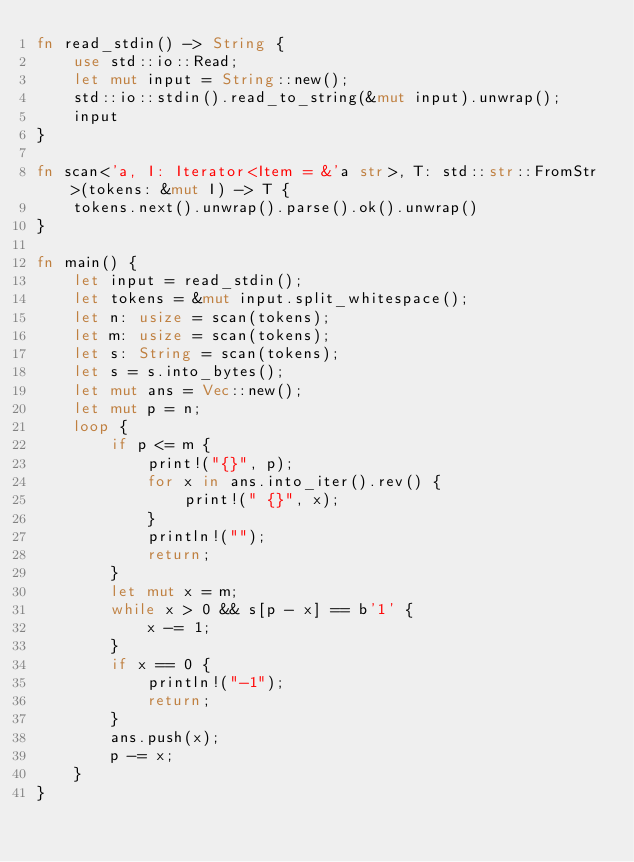<code> <loc_0><loc_0><loc_500><loc_500><_Rust_>fn read_stdin() -> String {
    use std::io::Read;
    let mut input = String::new();
    std::io::stdin().read_to_string(&mut input).unwrap();
    input
}

fn scan<'a, I: Iterator<Item = &'a str>, T: std::str::FromStr>(tokens: &mut I) -> T {
    tokens.next().unwrap().parse().ok().unwrap()
}

fn main() {
    let input = read_stdin();
    let tokens = &mut input.split_whitespace();
    let n: usize = scan(tokens);
    let m: usize = scan(tokens);
    let s: String = scan(tokens);
    let s = s.into_bytes();
    let mut ans = Vec::new();
    let mut p = n;
    loop {
        if p <= m {
            print!("{}", p);
            for x in ans.into_iter().rev() {
                print!(" {}", x);
            }
            println!("");
            return;
        }
        let mut x = m;
        while x > 0 && s[p - x] == b'1' {
            x -= 1;
        }
        if x == 0 {
            println!("-1");
            return;
        }
        ans.push(x);
        p -= x;
    }
}
</code> 